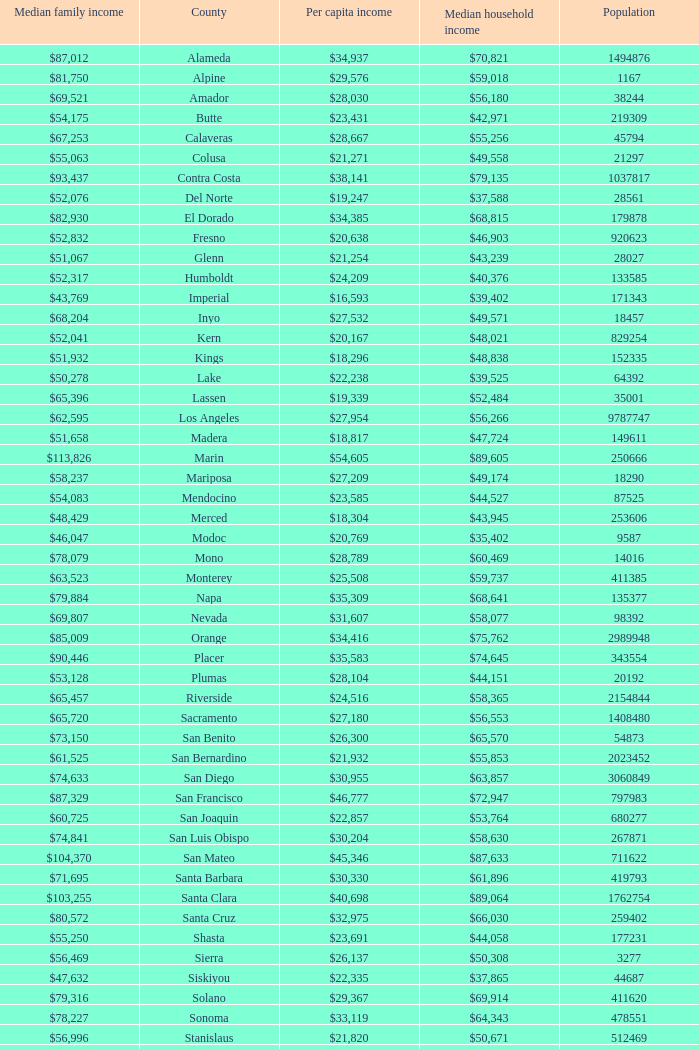What is the median household income of butte? $42,971. 